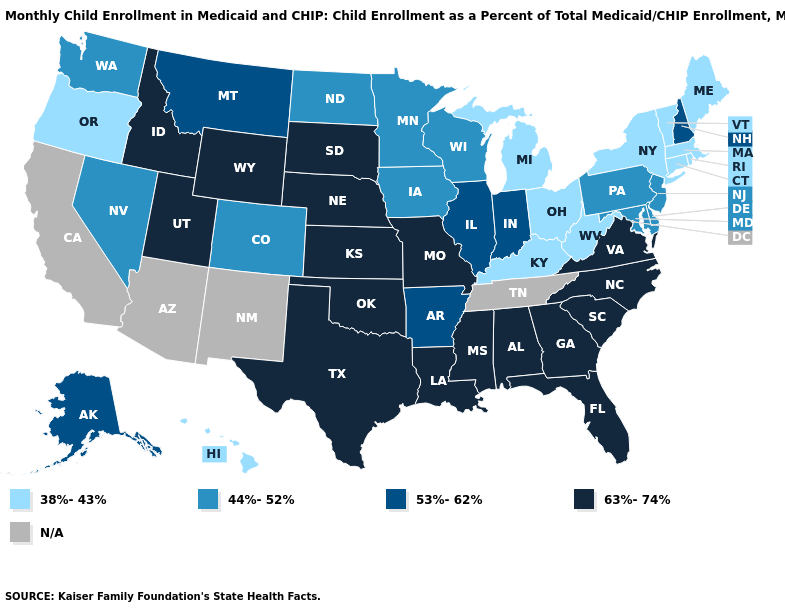Name the states that have a value in the range 53%-62%?
Answer briefly. Alaska, Arkansas, Illinois, Indiana, Montana, New Hampshire. What is the highest value in states that border Georgia?
Quick response, please. 63%-74%. What is the lowest value in the Northeast?
Concise answer only. 38%-43%. Name the states that have a value in the range 63%-74%?
Write a very short answer. Alabama, Florida, Georgia, Idaho, Kansas, Louisiana, Mississippi, Missouri, Nebraska, North Carolina, Oklahoma, South Carolina, South Dakota, Texas, Utah, Virginia, Wyoming. Name the states that have a value in the range 44%-52%?
Give a very brief answer. Colorado, Delaware, Iowa, Maryland, Minnesota, Nevada, New Jersey, North Dakota, Pennsylvania, Washington, Wisconsin. Does the map have missing data?
Be succinct. Yes. How many symbols are there in the legend?
Give a very brief answer. 5. Does the first symbol in the legend represent the smallest category?
Short answer required. Yes. Which states have the lowest value in the USA?
Short answer required. Connecticut, Hawaii, Kentucky, Maine, Massachusetts, Michigan, New York, Ohio, Oregon, Rhode Island, Vermont, West Virginia. Is the legend a continuous bar?
Keep it brief. No. Name the states that have a value in the range N/A?
Be succinct. Arizona, California, New Mexico, Tennessee. Among the states that border Minnesota , does Wisconsin have the lowest value?
Give a very brief answer. Yes. Which states hav the highest value in the Northeast?
Concise answer only. New Hampshire. Name the states that have a value in the range 44%-52%?
Keep it brief. Colorado, Delaware, Iowa, Maryland, Minnesota, Nevada, New Jersey, North Dakota, Pennsylvania, Washington, Wisconsin. 